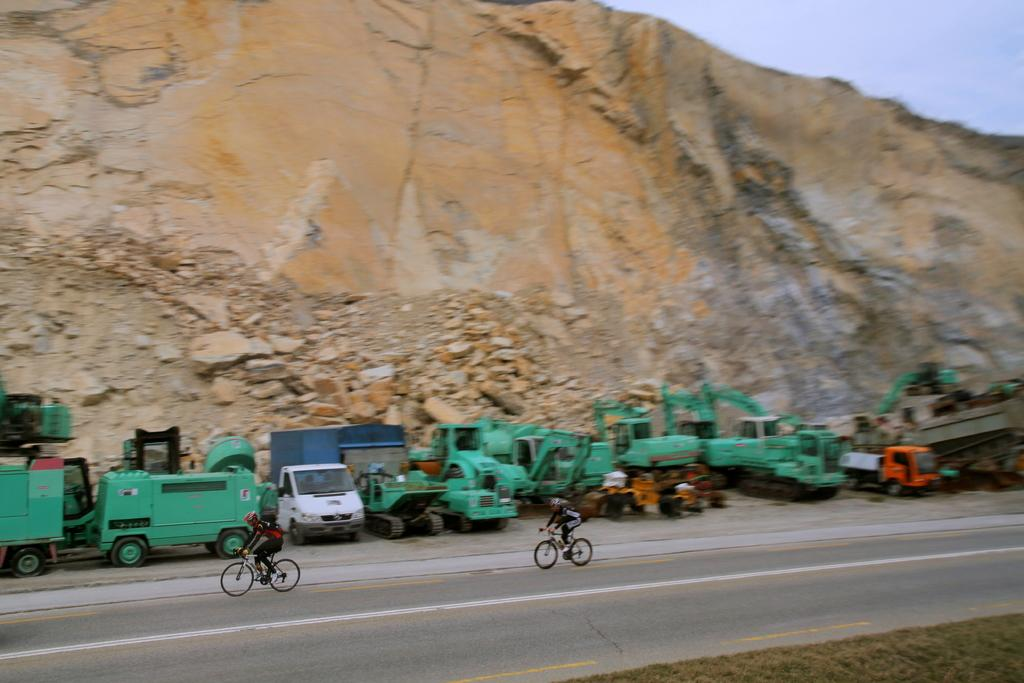What type of landscape feature is present in the image? There is a hill in the image. What are the two people doing in the image? They are riding bicycles in the image. What else can be seen in the image besides the hill and bicycles? There are vehicles in the image. What is visible in the background of the image? The sky is visible in the image. What type of wool is being used to create a gate in the image? There is no wool or gate present in the image. What type of plant is growing on the hill in the image? The provided facts do not mention any specific plants growing on the hill in the image. 